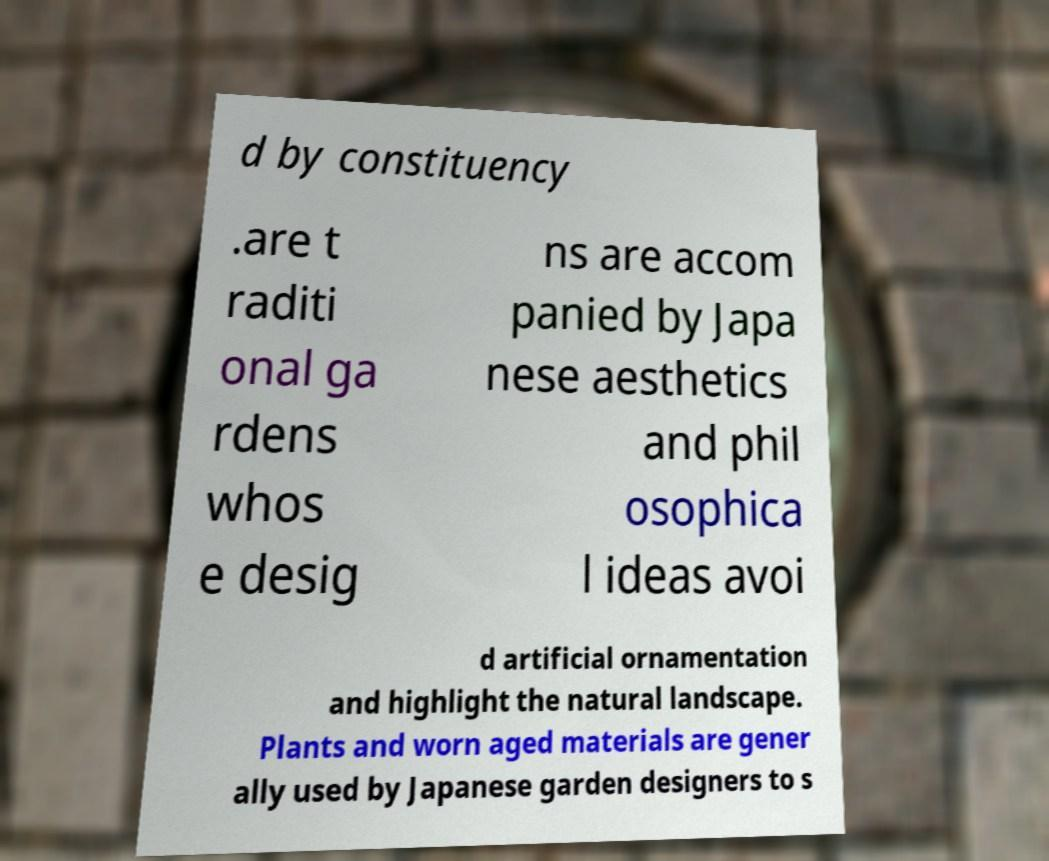There's text embedded in this image that I need extracted. Can you transcribe it verbatim? d by constituency .are t raditi onal ga rdens whos e desig ns are accom panied by Japa nese aesthetics and phil osophica l ideas avoi d artificial ornamentation and highlight the natural landscape. Plants and worn aged materials are gener ally used by Japanese garden designers to s 